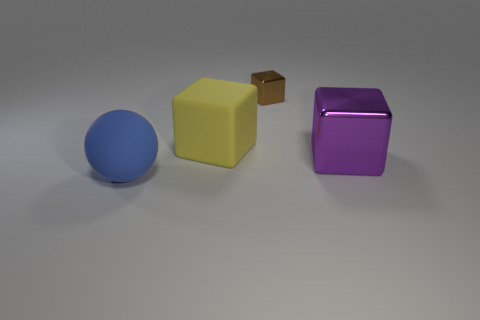Subtract all big blocks. How many blocks are left? 1 Subtract all spheres. How many objects are left? 3 Add 4 matte blocks. How many objects exist? 8 Subtract all green balls. Subtract all blue cylinders. How many balls are left? 1 Subtract all green cylinders. How many yellow balls are left? 0 Subtract all brown cubes. Subtract all small things. How many objects are left? 2 Add 2 large yellow rubber objects. How many large yellow rubber objects are left? 3 Add 1 big purple cubes. How many big purple cubes exist? 2 Subtract all yellow cubes. How many cubes are left? 2 Subtract 0 cyan cylinders. How many objects are left? 4 